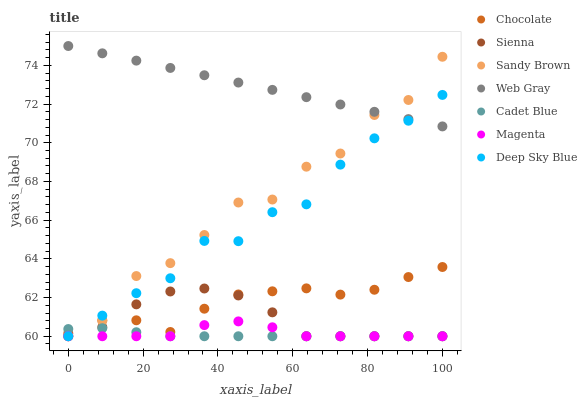Does Cadet Blue have the minimum area under the curve?
Answer yes or no. Yes. Does Web Gray have the maximum area under the curve?
Answer yes or no. Yes. Does Chocolate have the minimum area under the curve?
Answer yes or no. No. Does Chocolate have the maximum area under the curve?
Answer yes or no. No. Is Web Gray the smoothest?
Answer yes or no. Yes. Is Sandy Brown the roughest?
Answer yes or no. Yes. Is Chocolate the smoothest?
Answer yes or no. No. Is Chocolate the roughest?
Answer yes or no. No. Does Sienna have the lowest value?
Answer yes or no. Yes. Does Chocolate have the lowest value?
Answer yes or no. No. Does Web Gray have the highest value?
Answer yes or no. Yes. Does Chocolate have the highest value?
Answer yes or no. No. Is Chocolate less than Web Gray?
Answer yes or no. Yes. Is Web Gray greater than Chocolate?
Answer yes or no. Yes. Does Sienna intersect Chocolate?
Answer yes or no. Yes. Is Sienna less than Chocolate?
Answer yes or no. No. Is Sienna greater than Chocolate?
Answer yes or no. No. Does Chocolate intersect Web Gray?
Answer yes or no. No. 